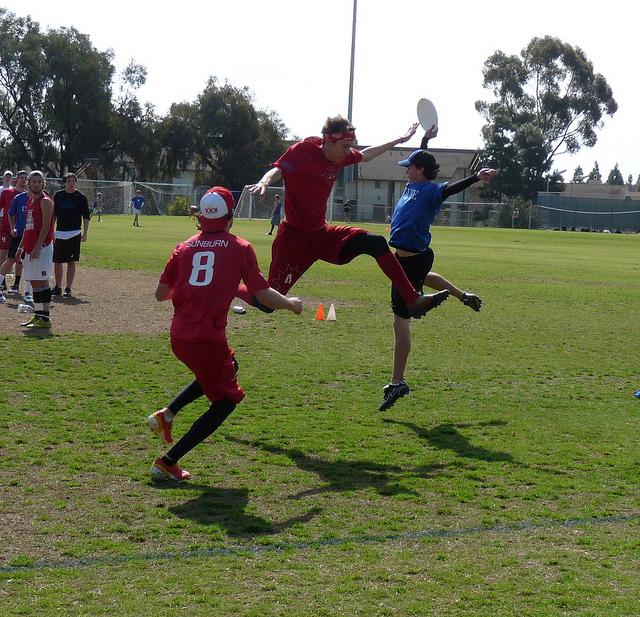What color is the hat on the mans head?
Keep it brief. Red and white. What is the color of the frisbee?
Answer briefly. White. Where are the trees?
Concise answer only. Background. Are they playing just for fun?
Write a very short answer. Yes. What number is on the back of the red shirt?
Quick response, please. 8. 